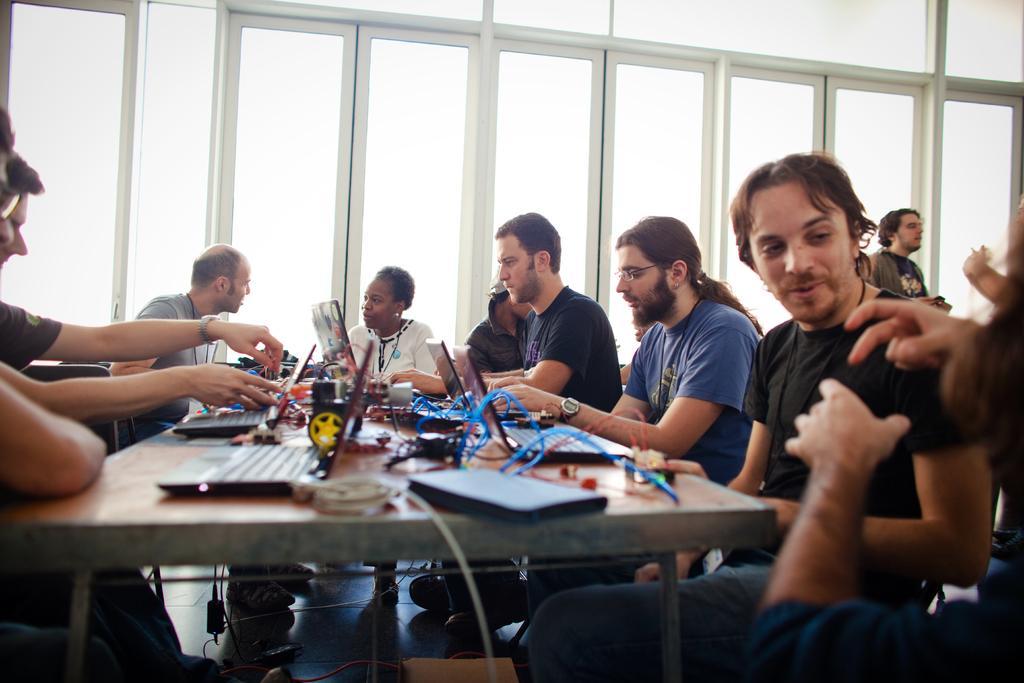In one or two sentences, can you explain what this image depicts? In this picture there are a group of people sitting and speaking with each other, there are laptops, cables kept on the table. In the backdrop there is a window. 